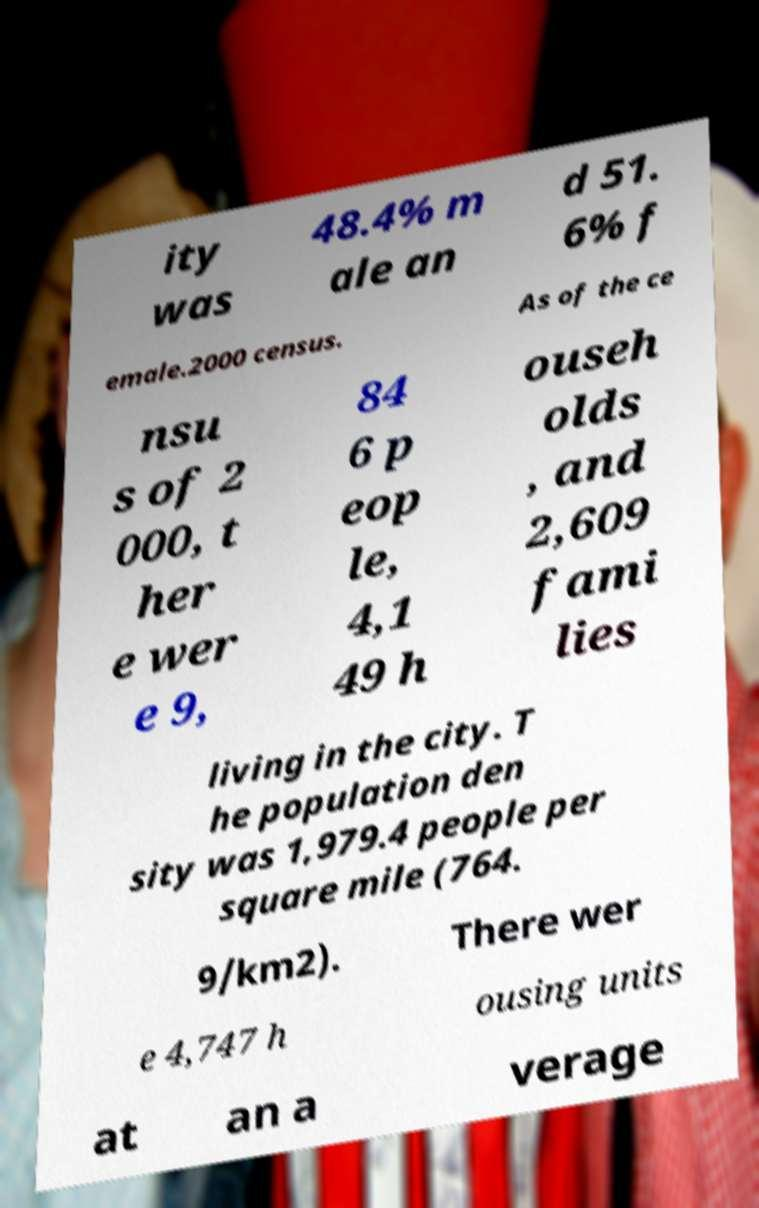Please identify and transcribe the text found in this image. ity was 48.4% m ale an d 51. 6% f emale.2000 census. As of the ce nsu s of 2 000, t her e wer e 9, 84 6 p eop le, 4,1 49 h ouseh olds , and 2,609 fami lies living in the city. T he population den sity was 1,979.4 people per square mile (764. 9/km2). There wer e 4,747 h ousing units at an a verage 